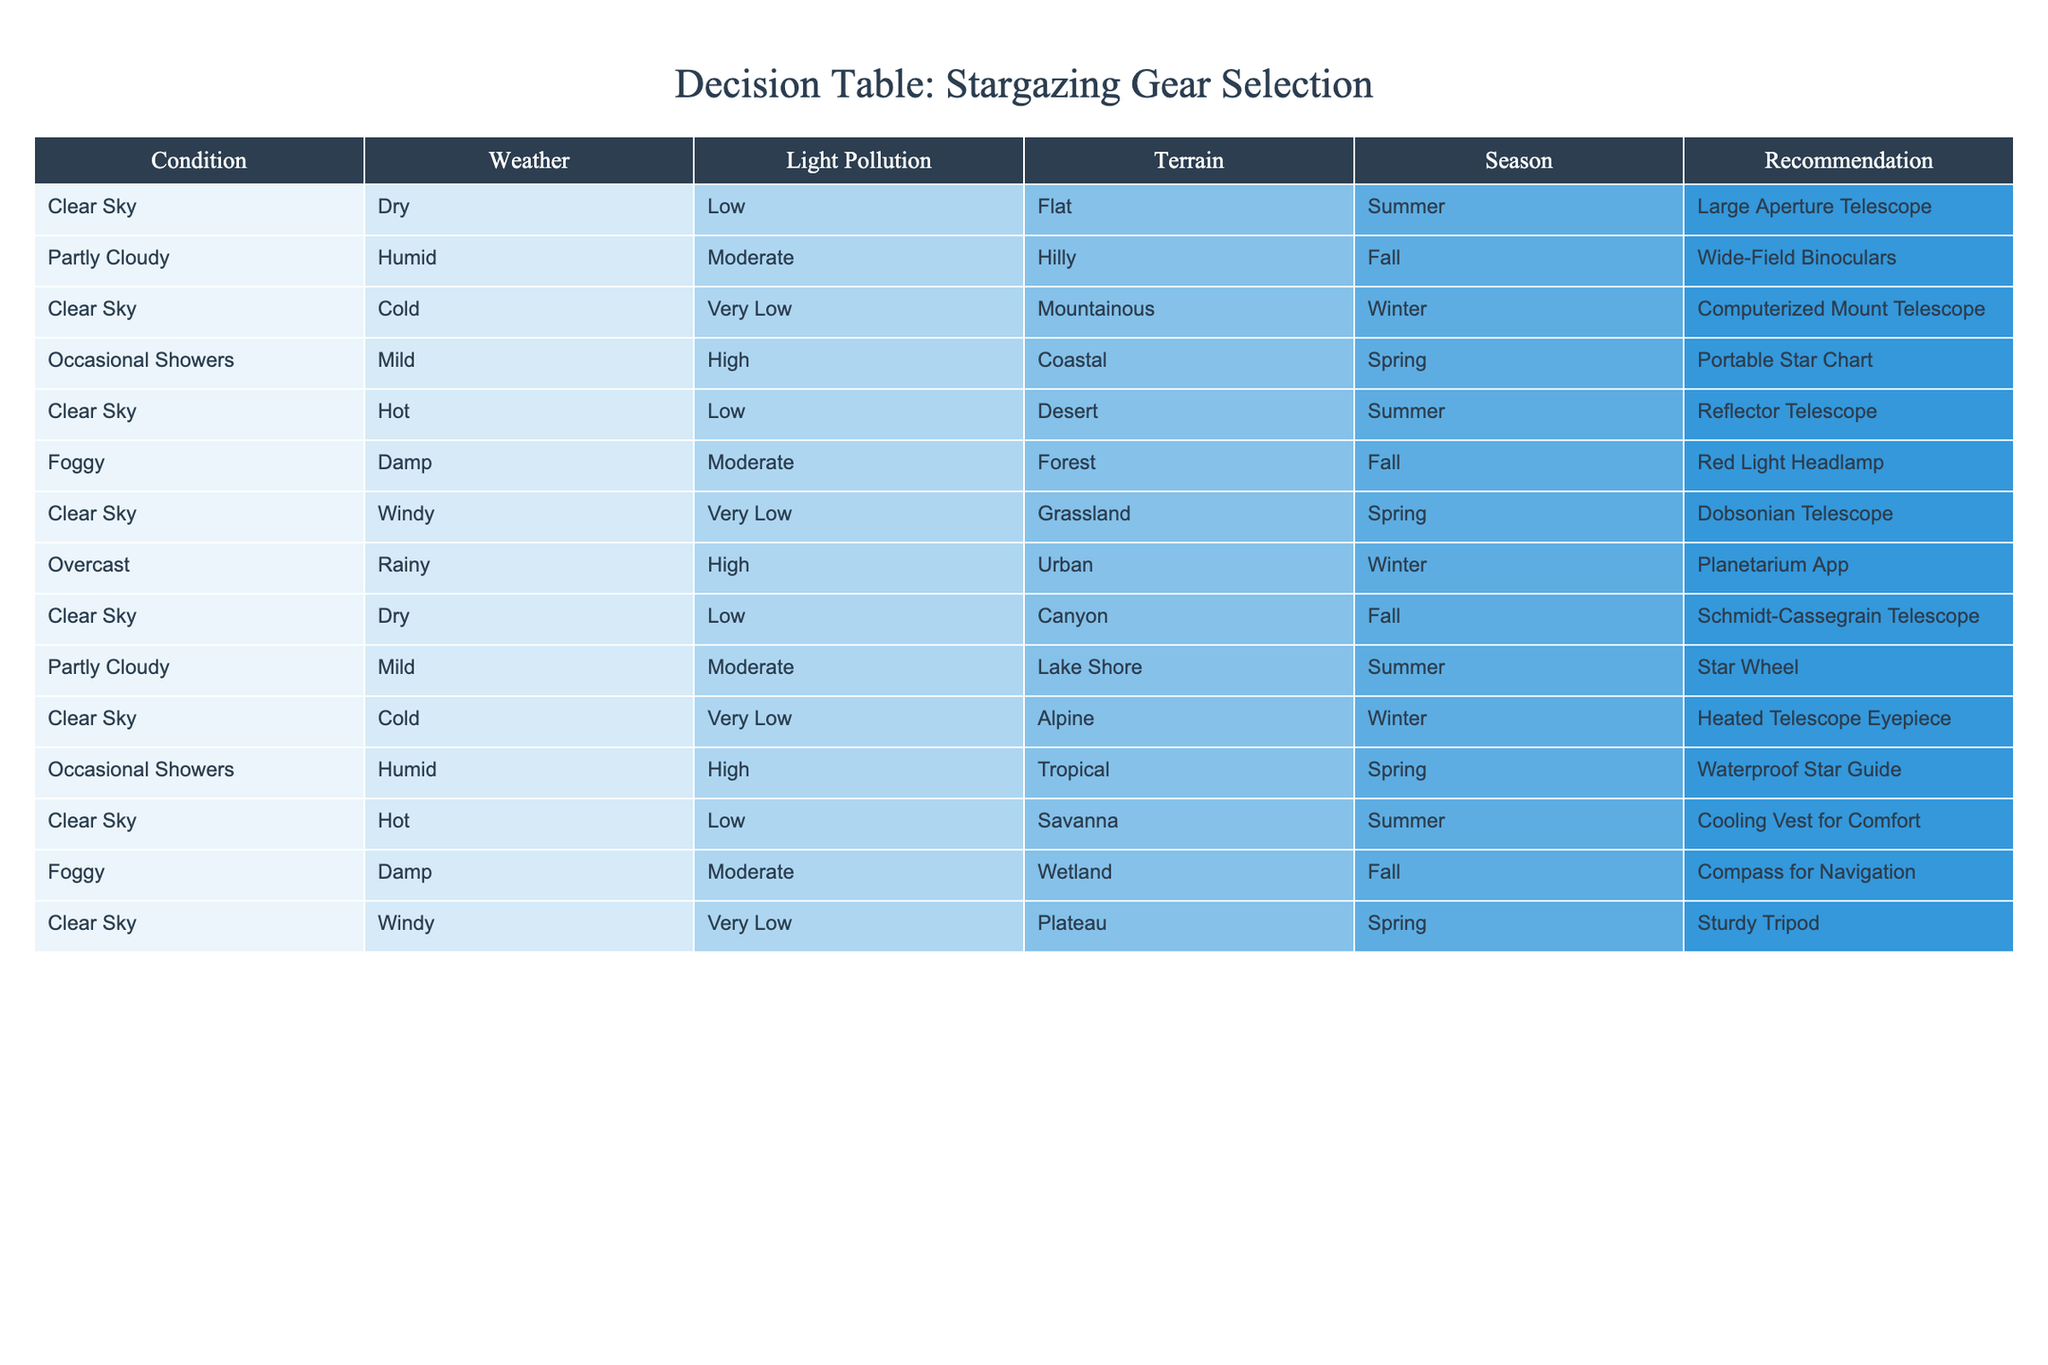What type of telescope is recommended for stargazing in a clear sky during summer? The table indicates that in a clear sky during summer, the recommended gear is a large aperture telescope. This information can be directly found in the respective row under the conditions specified.
Answer: Large Aperture Telescope Is a portable star chart suitable for occasional showers in the spring? According to the table, for occasional showers during spring, the recommendation is a portable star chart. Therefore, it is indeed suitable for this weather condition.
Answer: Yes How many different types of telescopes are suggested for clear skies? The table lists several types of telescopes for clear skies, specifically: large aperture telescope, computerized mount telescope, reflector telescope, dobsonian telescope, and schmidt-cassegrain telescope. Counting these gives us five different types.
Answer: 5 In what conditions is a cooling vest for comfort recommended? The cooling vest for comfort is recommended when the sky is clear, it's hot, and the environment is a savanna during summer. This can be verified by checking the conditions in the respective row.
Answer: Clear Sky, Hot, Savanna, Summer What is the recommended gear if the weather is overcast and rainy in winter? The table specifies that for overcast and rainy weather in winter, a planetarium app is recommended. This is clearly laid out in the corresponding row under those specific conditions.
Answer: Planetarium App Is there a recommendation for stargazing in a foggy condition during fall? The table indicates that during foggy conditions in fall, a red light headlamp is the recommended gear. Thus, there is indeed a recommendation for these conditions.
Answer: Yes What equipment is advised for a windy, clear sky in spring? The recommendation for a windy, clear sky in spring is a sturdy tripod. This is found in the specific row matching these criteria.
Answer: Sturdy Tripod Which type of gear is suggested for stargazing in a coastal area during mild weather? For mild weather in a coastal area, the table suggests a compass for navigation. This recommendation is found under the specific conditions mentioned.
Answer: Compass for Navigation If the light pollution is high, is a reflector telescope a good choice? The data shows that a reflector telescope is recommended in a low light pollution context. With high light pollution, the table doesn't list a reflector telescope, indicating it's not a good choice for high light pollution.
Answer: No 